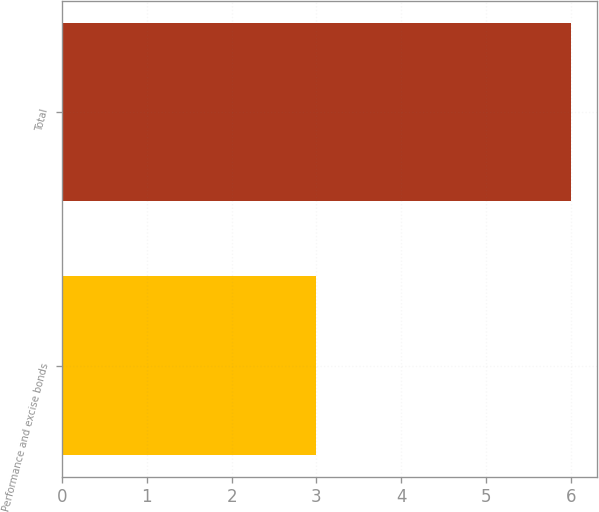Convert chart to OTSL. <chart><loc_0><loc_0><loc_500><loc_500><bar_chart><fcel>Performance and excise bonds<fcel>Total<nl><fcel>3<fcel>6<nl></chart> 